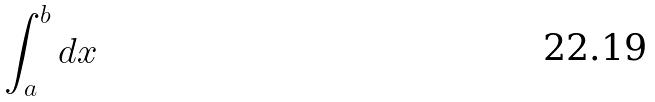<formula> <loc_0><loc_0><loc_500><loc_500>\int _ { a } ^ { b } d x</formula> 